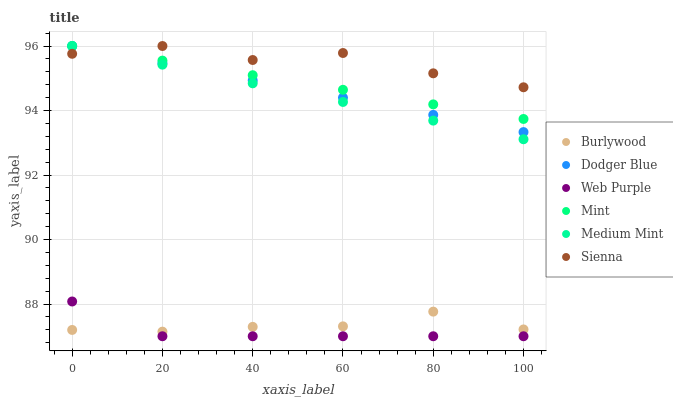Does Web Purple have the minimum area under the curve?
Answer yes or no. Yes. Does Sienna have the maximum area under the curve?
Answer yes or no. Yes. Does Burlywood have the minimum area under the curve?
Answer yes or no. No. Does Burlywood have the maximum area under the curve?
Answer yes or no. No. Is Medium Mint the smoothest?
Answer yes or no. Yes. Is Sienna the roughest?
Answer yes or no. Yes. Is Burlywood the smoothest?
Answer yes or no. No. Is Burlywood the roughest?
Answer yes or no. No. Does Web Purple have the lowest value?
Answer yes or no. Yes. Does Burlywood have the lowest value?
Answer yes or no. No. Does Mint have the highest value?
Answer yes or no. Yes. Does Burlywood have the highest value?
Answer yes or no. No. Is Web Purple less than Mint?
Answer yes or no. Yes. Is Dodger Blue greater than Burlywood?
Answer yes or no. Yes. Does Sienna intersect Dodger Blue?
Answer yes or no. Yes. Is Sienna less than Dodger Blue?
Answer yes or no. No. Is Sienna greater than Dodger Blue?
Answer yes or no. No. Does Web Purple intersect Mint?
Answer yes or no. No. 